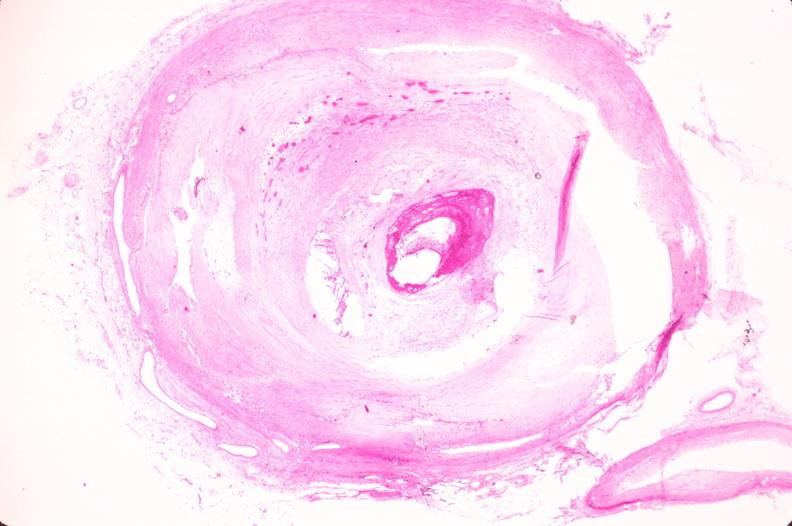does this image show coronary artery atherosclerosis?
Answer the question using a single word or phrase. Yes 